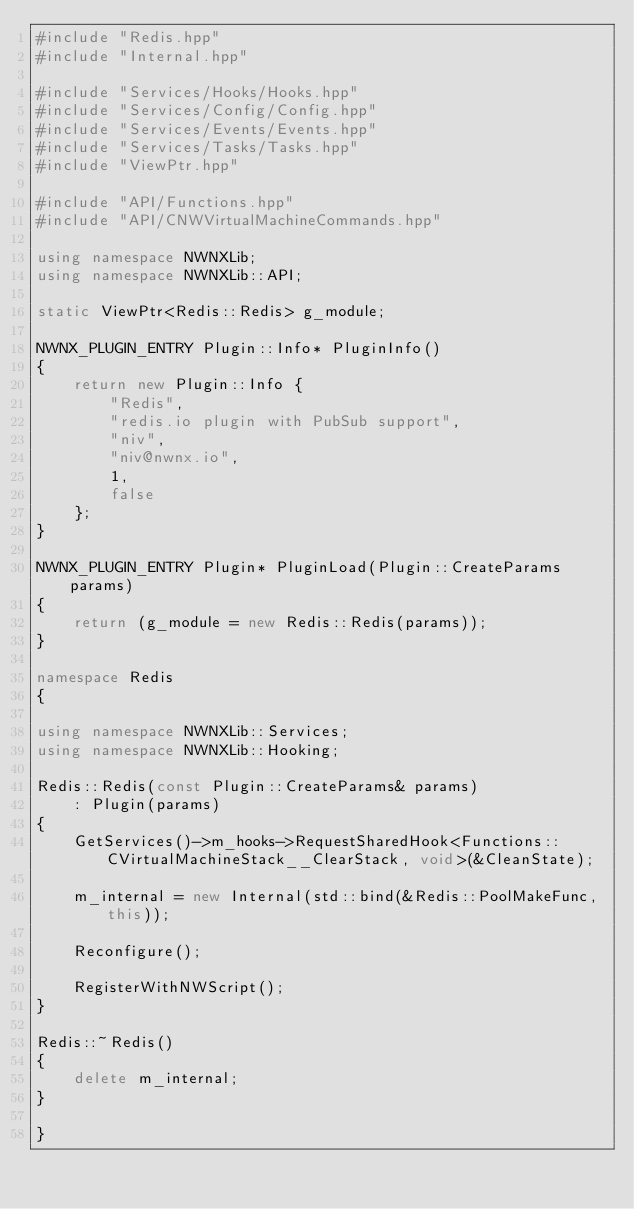<code> <loc_0><loc_0><loc_500><loc_500><_C++_>#include "Redis.hpp"
#include "Internal.hpp"

#include "Services/Hooks/Hooks.hpp"
#include "Services/Config/Config.hpp"
#include "Services/Events/Events.hpp"
#include "Services/Tasks/Tasks.hpp"
#include "ViewPtr.hpp"

#include "API/Functions.hpp"
#include "API/CNWVirtualMachineCommands.hpp"

using namespace NWNXLib;
using namespace NWNXLib::API;

static ViewPtr<Redis::Redis> g_module;

NWNX_PLUGIN_ENTRY Plugin::Info* PluginInfo()
{
    return new Plugin::Info {
        "Redis",
        "redis.io plugin with PubSub support",
        "niv",
        "niv@nwnx.io",
        1,
        false
    };
}

NWNX_PLUGIN_ENTRY Plugin* PluginLoad(Plugin::CreateParams params)
{
    return (g_module = new Redis::Redis(params));
}

namespace Redis
{

using namespace NWNXLib::Services;
using namespace NWNXLib::Hooking;

Redis::Redis(const Plugin::CreateParams& params)
    : Plugin(params)
{
    GetServices()->m_hooks->RequestSharedHook<Functions::CVirtualMachineStack__ClearStack, void>(&CleanState);

    m_internal = new Internal(std::bind(&Redis::PoolMakeFunc, this));

    Reconfigure();

    RegisterWithNWScript();
}

Redis::~Redis()
{
    delete m_internal;
}

}
</code> 